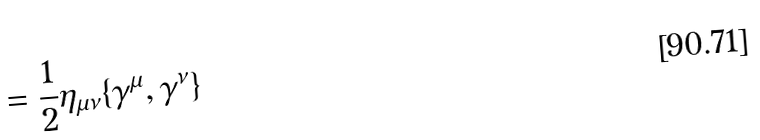Convert formula to latex. <formula><loc_0><loc_0><loc_500><loc_500>= \frac { 1 } { 2 } \eta _ { \mu \nu } \{ \gamma ^ { \mu } , \gamma ^ { \nu } \}</formula> 